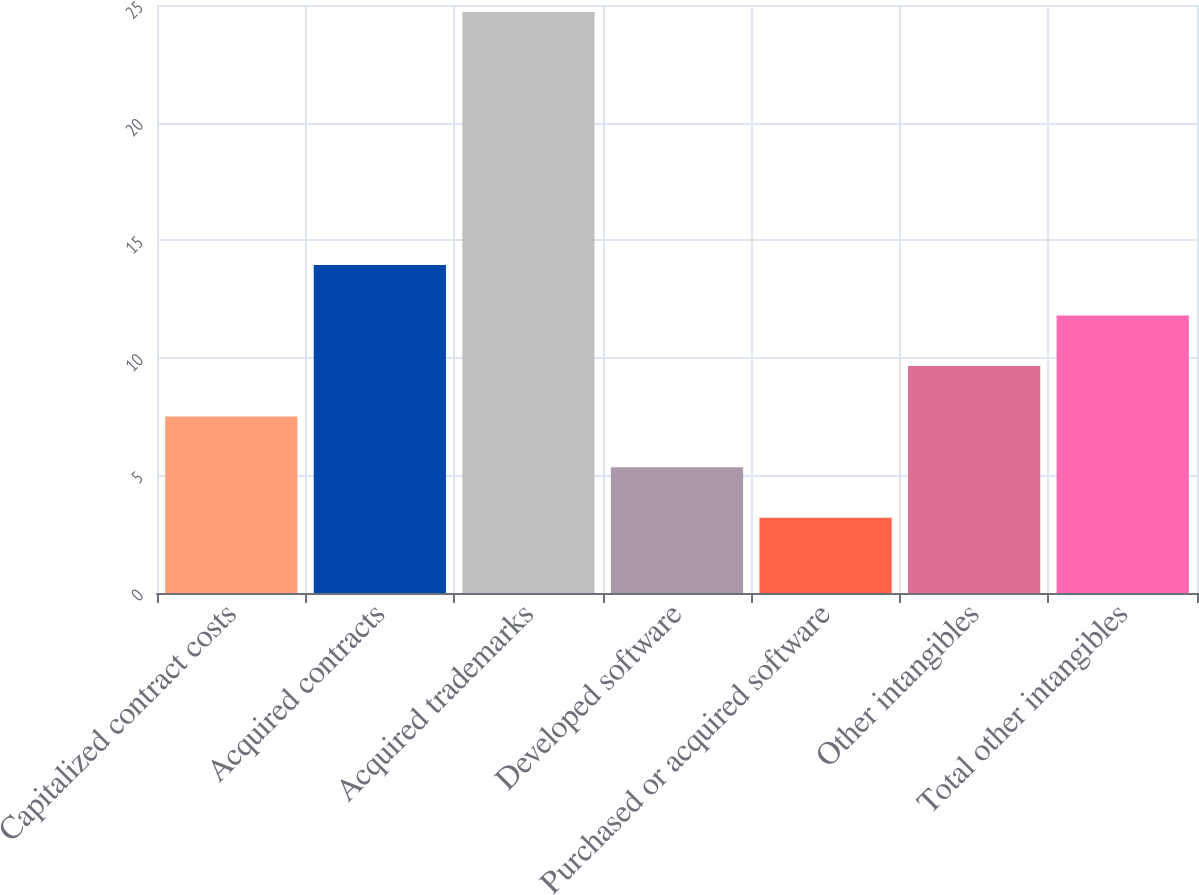Convert chart to OTSL. <chart><loc_0><loc_0><loc_500><loc_500><bar_chart><fcel>Capitalized contract costs<fcel>Acquired contracts<fcel>Acquired trademarks<fcel>Developed software<fcel>Purchased or acquired software<fcel>Other intangibles<fcel>Total other intangibles<nl><fcel>7.5<fcel>13.95<fcel>24.7<fcel>5.35<fcel>3.2<fcel>9.65<fcel>11.8<nl></chart> 